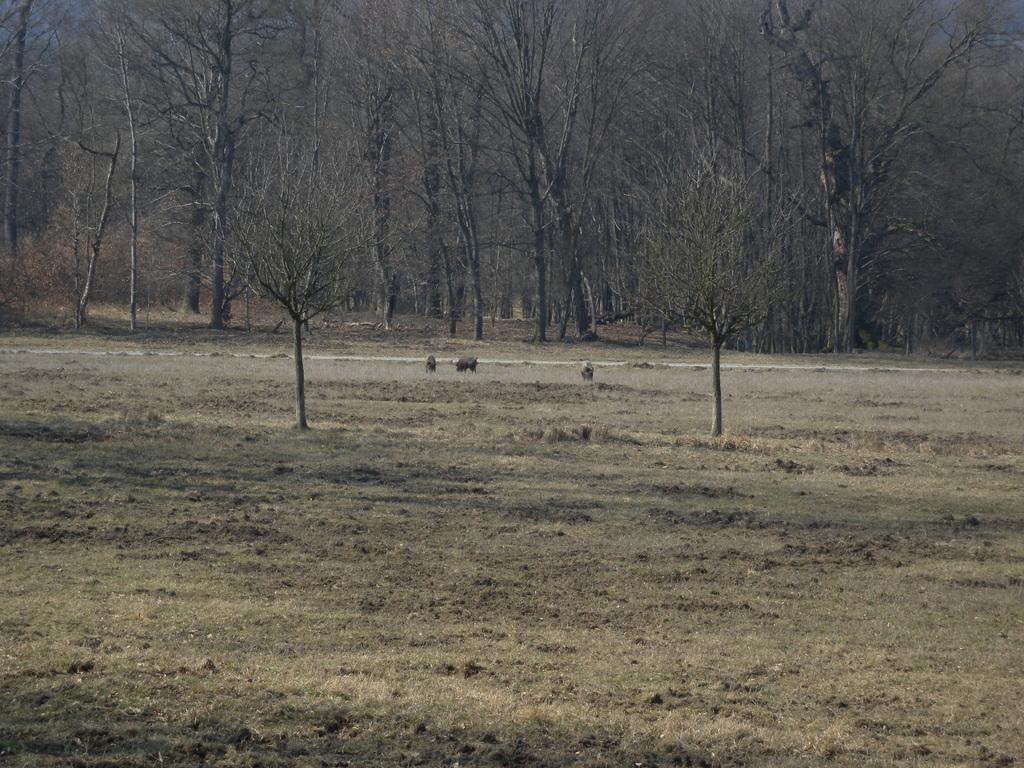What is the main feature of the foreground in the image? There is empty land in the foreground of the image. What can be seen in the background of the image? There are trees in the background of the image. How high does the kite fly in the image? There is no kite present in the image, so it cannot be determined how high a kite might fly. 